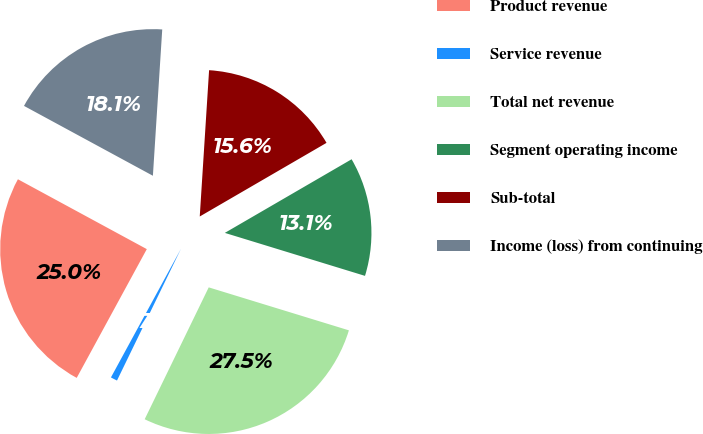Convert chart to OTSL. <chart><loc_0><loc_0><loc_500><loc_500><pie_chart><fcel>Product revenue<fcel>Service revenue<fcel>Total net revenue<fcel>Segment operating income<fcel>Sub-total<fcel>Income (loss) from continuing<nl><fcel>24.97%<fcel>0.74%<fcel>27.46%<fcel>13.11%<fcel>15.61%<fcel>18.11%<nl></chart> 